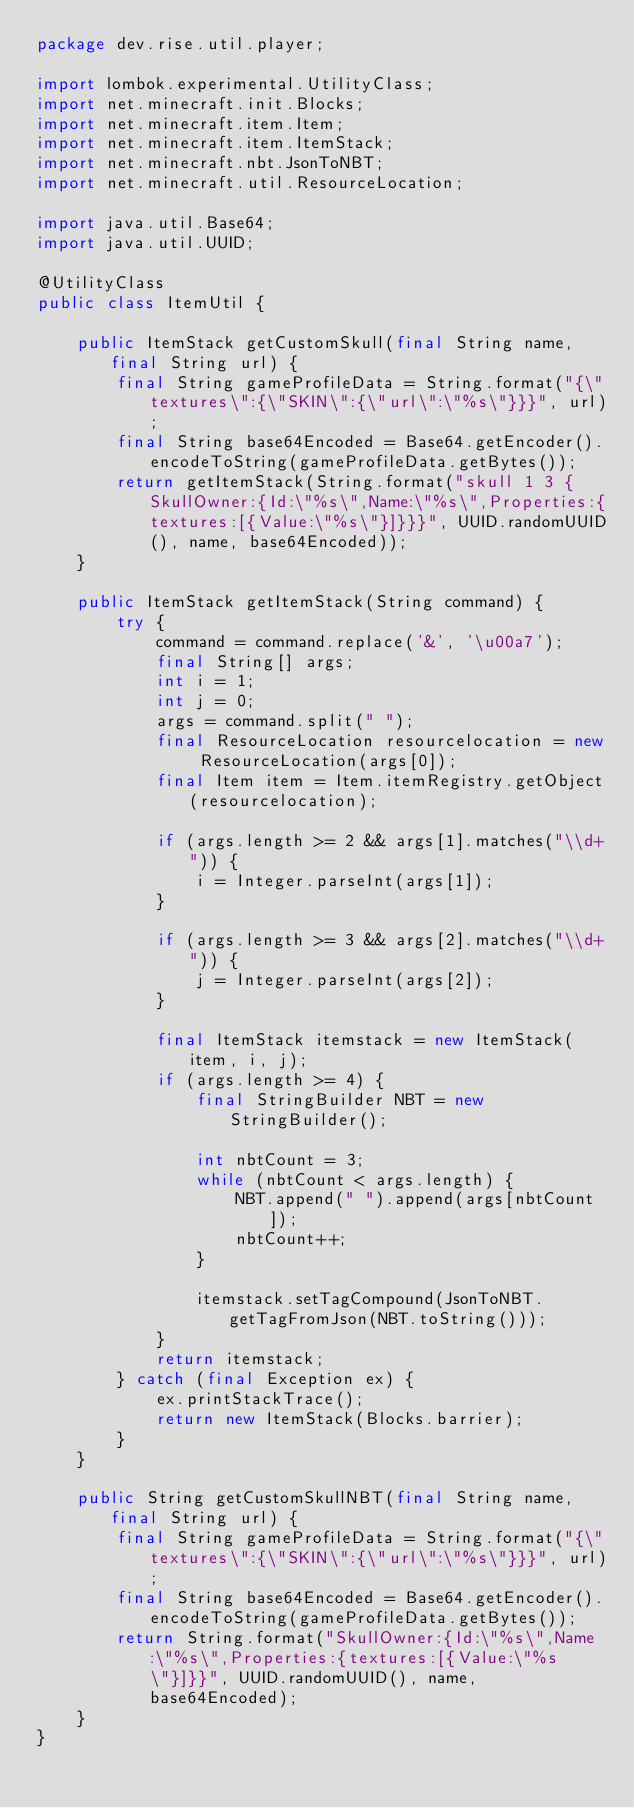Convert code to text. <code><loc_0><loc_0><loc_500><loc_500><_Java_>package dev.rise.util.player;

import lombok.experimental.UtilityClass;
import net.minecraft.init.Blocks;
import net.minecraft.item.Item;
import net.minecraft.item.ItemStack;
import net.minecraft.nbt.JsonToNBT;
import net.minecraft.util.ResourceLocation;

import java.util.Base64;
import java.util.UUID;

@UtilityClass
public class ItemUtil {

    public ItemStack getCustomSkull(final String name, final String url) {
        final String gameProfileData = String.format("{\"textures\":{\"SKIN\":{\"url\":\"%s\"}}}", url);
        final String base64Encoded = Base64.getEncoder().encodeToString(gameProfileData.getBytes());
        return getItemStack(String.format("skull 1 3 {SkullOwner:{Id:\"%s\",Name:\"%s\",Properties:{textures:[{Value:\"%s\"}]}}}", UUID.randomUUID(), name, base64Encoded));
    }

    public ItemStack getItemStack(String command) {
        try {
            command = command.replace('&', '\u00a7');
            final String[] args;
            int i = 1;
            int j = 0;
            args = command.split(" ");
            final ResourceLocation resourcelocation = new ResourceLocation(args[0]);
            final Item item = Item.itemRegistry.getObject(resourcelocation);

            if (args.length >= 2 && args[1].matches("\\d+")) {
                i = Integer.parseInt(args[1]);
            }

            if (args.length >= 3 && args[2].matches("\\d+")) {
                j = Integer.parseInt(args[2]);
            }

            final ItemStack itemstack = new ItemStack(item, i, j);
            if (args.length >= 4) {
                final StringBuilder NBT = new StringBuilder();

                int nbtCount = 3;
                while (nbtCount < args.length) {
                    NBT.append(" ").append(args[nbtCount]);
                    nbtCount++;
                }

                itemstack.setTagCompound(JsonToNBT.getTagFromJson(NBT.toString()));
            }
            return itemstack;
        } catch (final Exception ex) {
            ex.printStackTrace();
            return new ItemStack(Blocks.barrier);
        }
    }

    public String getCustomSkullNBT(final String name, final String url) {
        final String gameProfileData = String.format("{\"textures\":{\"SKIN\":{\"url\":\"%s\"}}}", url);
        final String base64Encoded = Base64.getEncoder().encodeToString(gameProfileData.getBytes());
        return String.format("SkullOwner:{Id:\"%s\",Name:\"%s\",Properties:{textures:[{Value:\"%s\"}]}}", UUID.randomUUID(), name, base64Encoded);
    }
}
</code> 